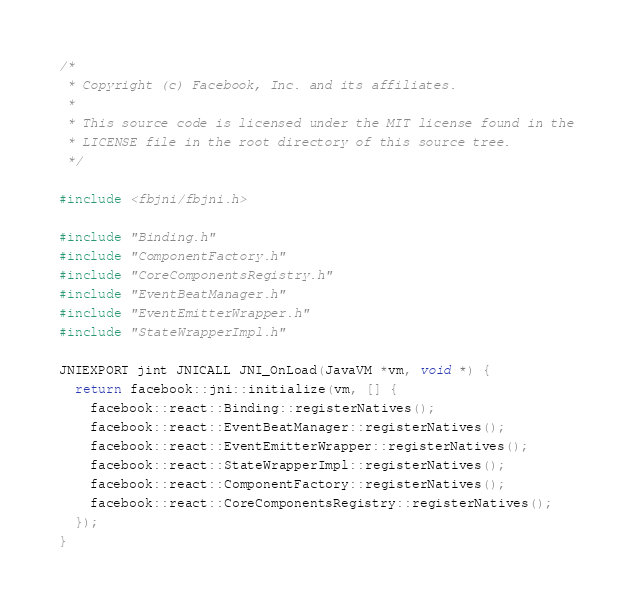<code> <loc_0><loc_0><loc_500><loc_500><_C++_>/*
 * Copyright (c) Facebook, Inc. and its affiliates.
 *
 * This source code is licensed under the MIT license found in the
 * LICENSE file in the root directory of this source tree.
 */

#include <fbjni/fbjni.h>

#include "Binding.h"
#include "ComponentFactory.h"
#include "CoreComponentsRegistry.h"
#include "EventBeatManager.h"
#include "EventEmitterWrapper.h"
#include "StateWrapperImpl.h"

JNIEXPORT jint JNICALL JNI_OnLoad(JavaVM *vm, void *) {
  return facebook::jni::initialize(vm, [] {
    facebook::react::Binding::registerNatives();
    facebook::react::EventBeatManager::registerNatives();
    facebook::react::EventEmitterWrapper::registerNatives();
    facebook::react::StateWrapperImpl::registerNatives();
    facebook::react::ComponentFactory::registerNatives();
    facebook::react::CoreComponentsRegistry::registerNatives();
  });
}
</code> 